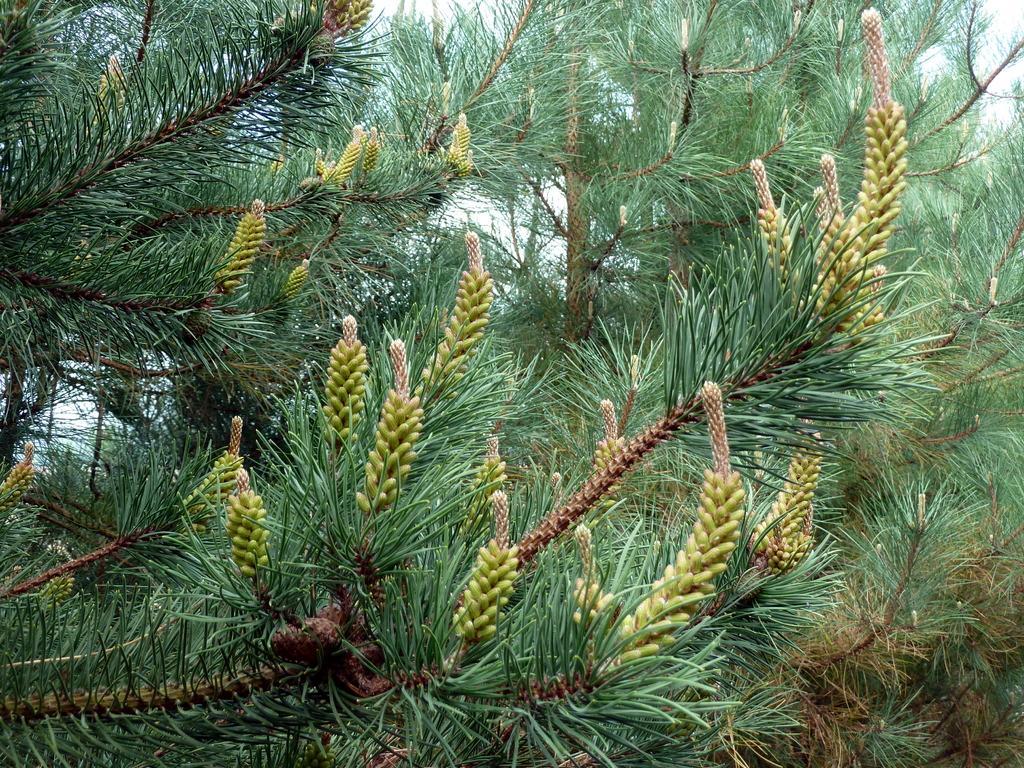In one or two sentences, can you explain what this image depicts? In this image I can see few trees in green color. In the background I can see the sky in white color. 